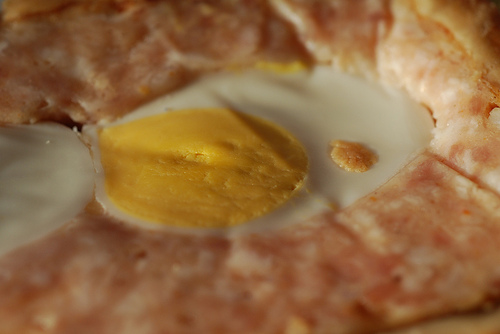<image>
Is the food in front of the food? Yes. The food is positioned in front of the food, appearing closer to the camera viewpoint. 